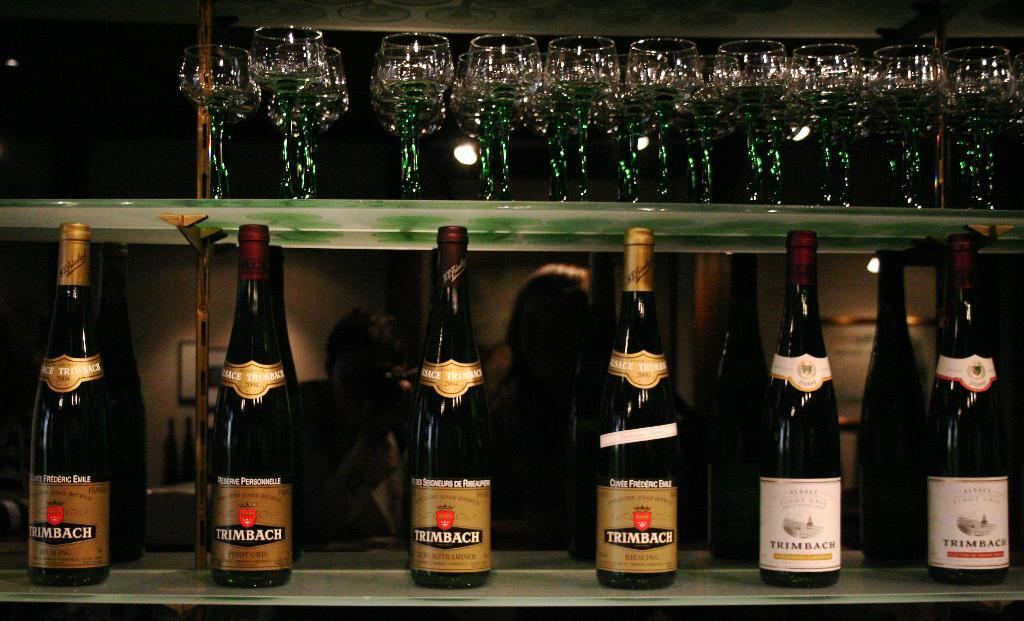<image>
Describe the image concisely. A row of Trimbach wine bottles are lined up under a shelf of glasses. 